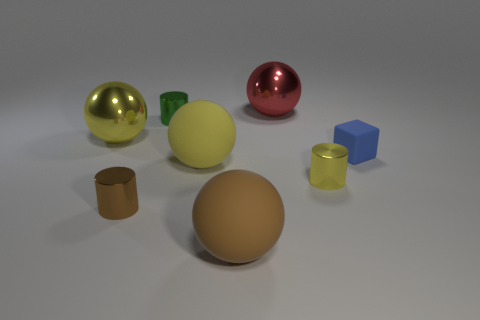Subtract all big red balls. How many balls are left? 3 Add 1 small brown cubes. How many objects exist? 9 Subtract all red spheres. How many spheres are left? 3 Subtract all blocks. How many objects are left? 7 Subtract all gray spheres. How many blue cylinders are left? 0 Subtract 1 red balls. How many objects are left? 7 Subtract 1 cubes. How many cubes are left? 0 Subtract all blue cylinders. Subtract all brown cubes. How many cylinders are left? 3 Subtract all red shiny balls. Subtract all blue cubes. How many objects are left? 6 Add 4 brown things. How many brown things are left? 6 